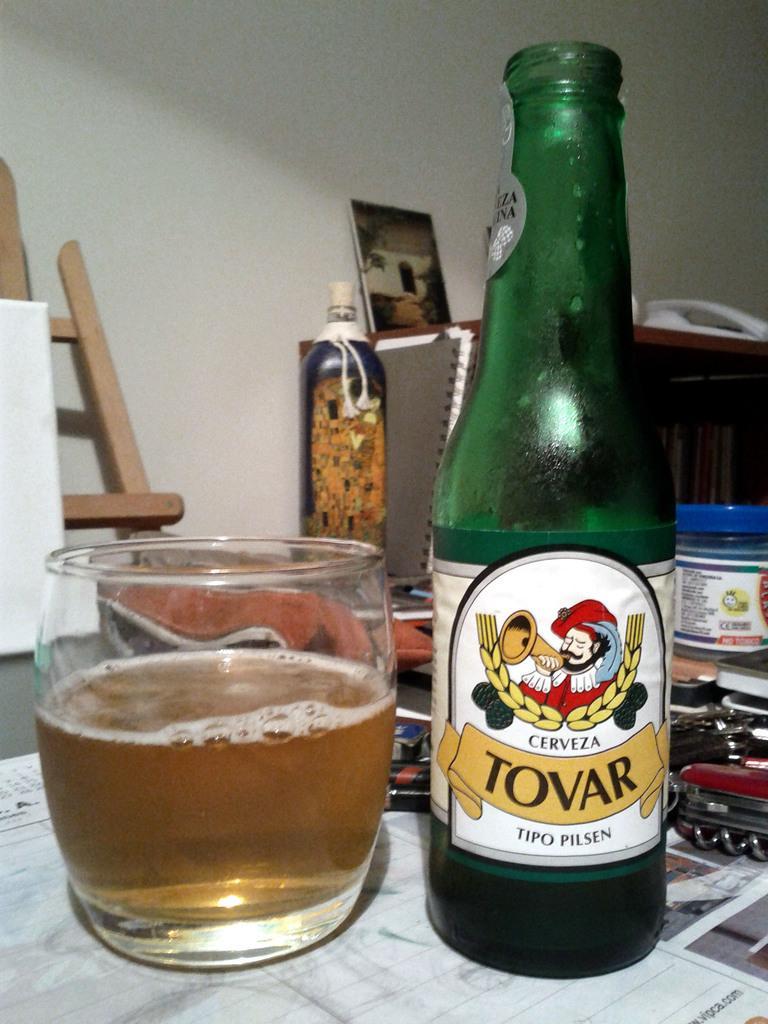Could you give a brief overview of what you see in this image? There is a table. There is a cup and bottle on a table. We can see in background photo frame and wall. 